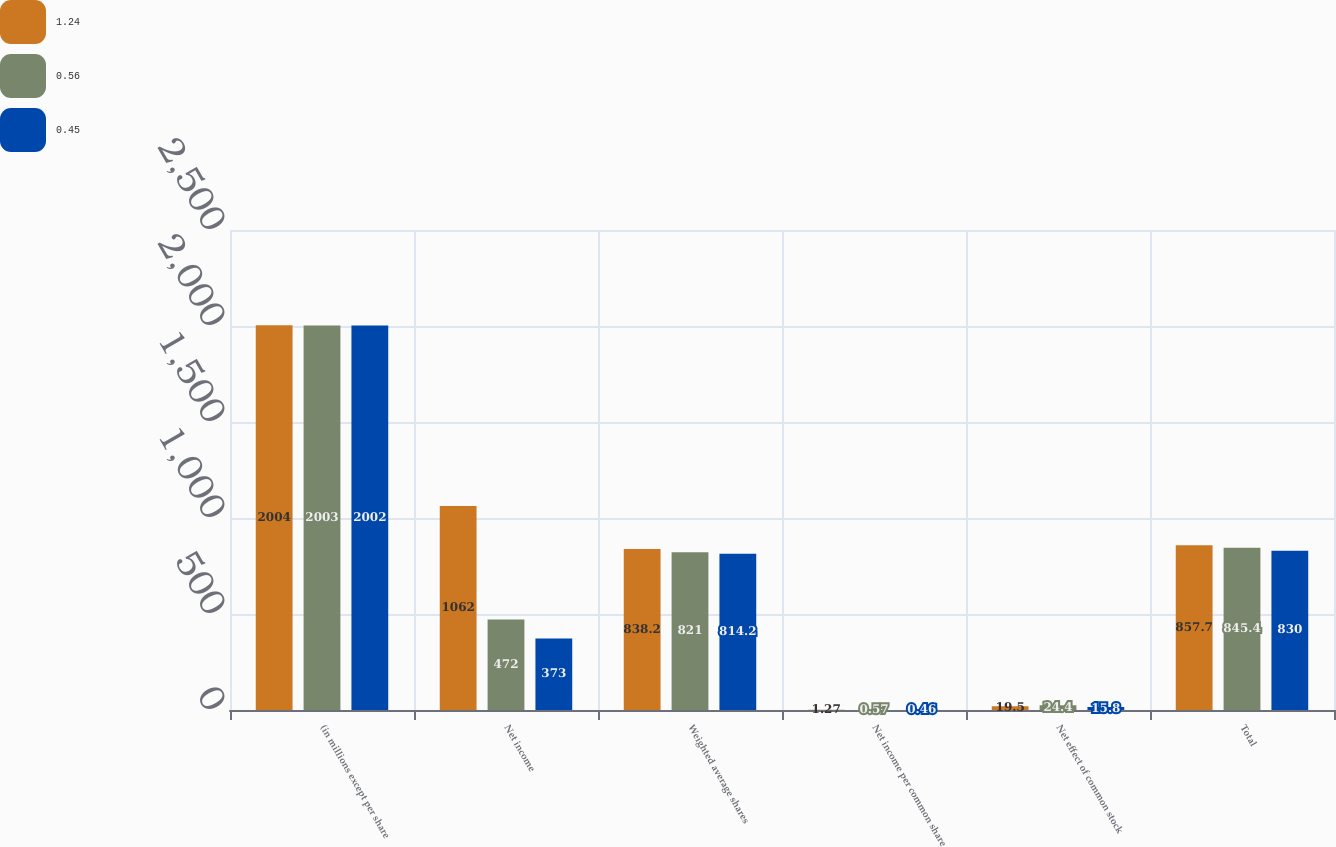<chart> <loc_0><loc_0><loc_500><loc_500><stacked_bar_chart><ecel><fcel>(in millions except per share<fcel>Net income<fcel>Weighted average shares<fcel>Net income per common share<fcel>Net effect of common stock<fcel>Total<nl><fcel>1.24<fcel>2004<fcel>1062<fcel>838.2<fcel>1.27<fcel>19.5<fcel>857.7<nl><fcel>0.56<fcel>2003<fcel>472<fcel>821<fcel>0.57<fcel>24.4<fcel>845.4<nl><fcel>0.45<fcel>2002<fcel>373<fcel>814.2<fcel>0.46<fcel>15.8<fcel>830<nl></chart> 